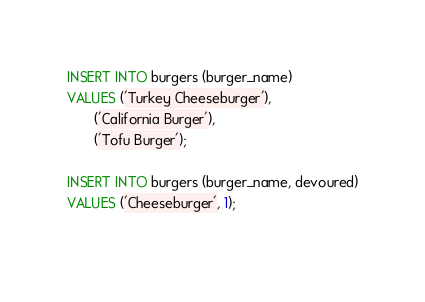Convert code to text. <code><loc_0><loc_0><loc_500><loc_500><_SQL_>INSERT INTO burgers (burger_name)
VALUES ('Turkey Cheeseburger'),
       ('California Burger'),
       ('Tofu Burger');

INSERT INTO burgers (burger_name, devoured)
VALUES ('Cheeseburger', 1);
       
</code> 